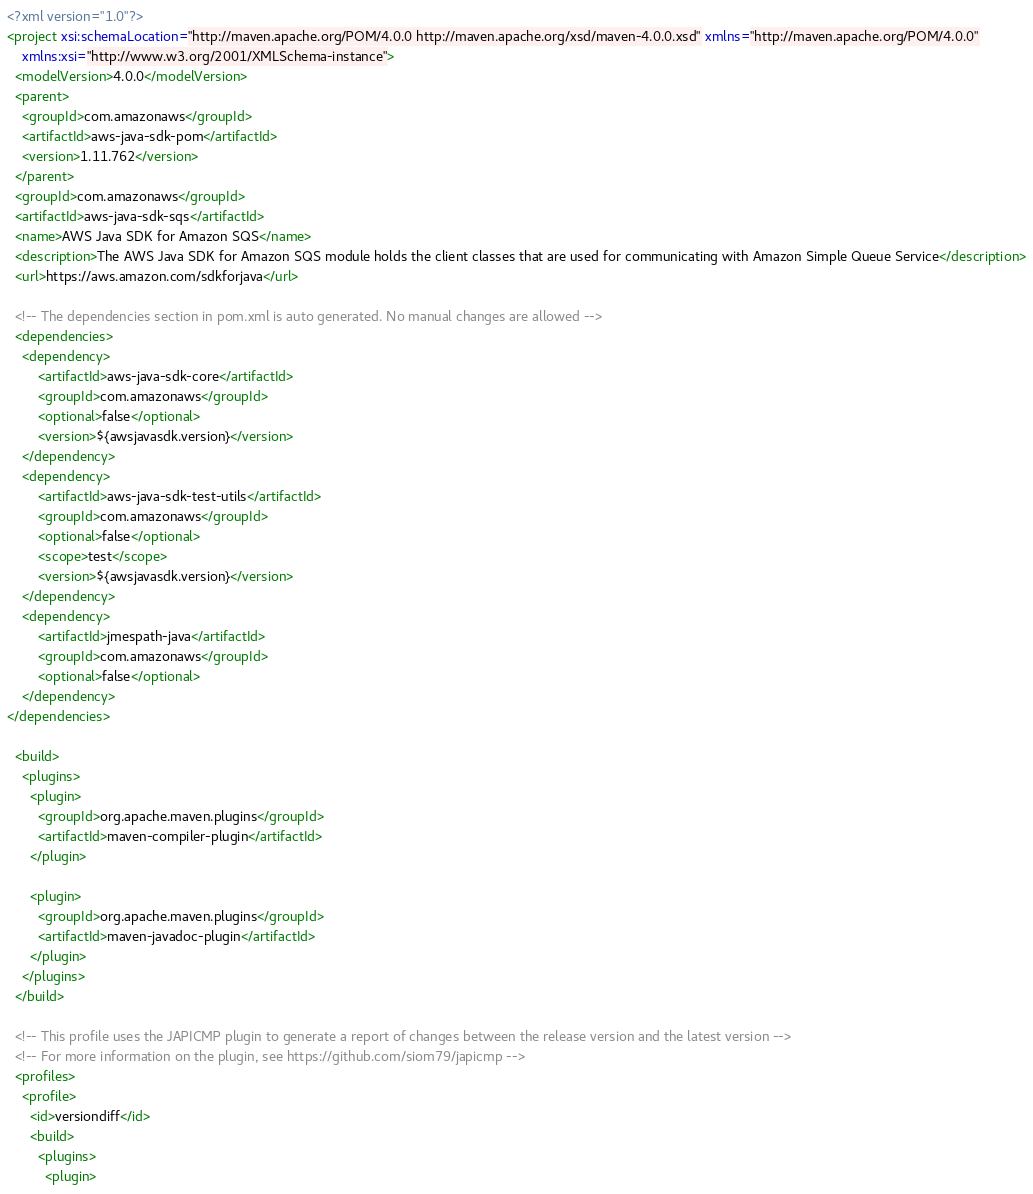Convert code to text. <code><loc_0><loc_0><loc_500><loc_500><_XML_><?xml version="1.0"?>
<project xsi:schemaLocation="http://maven.apache.org/POM/4.0.0 http://maven.apache.org/xsd/maven-4.0.0.xsd" xmlns="http://maven.apache.org/POM/4.0.0"
    xmlns:xsi="http://www.w3.org/2001/XMLSchema-instance">
  <modelVersion>4.0.0</modelVersion>
  <parent>
    <groupId>com.amazonaws</groupId>
    <artifactId>aws-java-sdk-pom</artifactId>
    <version>1.11.762</version>
  </parent>
  <groupId>com.amazonaws</groupId>
  <artifactId>aws-java-sdk-sqs</artifactId>
  <name>AWS Java SDK for Amazon SQS</name>
  <description>The AWS Java SDK for Amazon SQS module holds the client classes that are used for communicating with Amazon Simple Queue Service</description>
  <url>https://aws.amazon.com/sdkforjava</url>

  <!-- The dependencies section in pom.xml is auto generated. No manual changes are allowed -->
  <dependencies>
    <dependency>
        <artifactId>aws-java-sdk-core</artifactId>
        <groupId>com.amazonaws</groupId>
        <optional>false</optional>
        <version>${awsjavasdk.version}</version>
    </dependency>
    <dependency>
        <artifactId>aws-java-sdk-test-utils</artifactId>
        <groupId>com.amazonaws</groupId>
        <optional>false</optional>
        <scope>test</scope>
        <version>${awsjavasdk.version}</version>
    </dependency>
    <dependency>
        <artifactId>jmespath-java</artifactId>
        <groupId>com.amazonaws</groupId>
        <optional>false</optional>
    </dependency>
</dependencies>

  <build>
    <plugins>
      <plugin>
        <groupId>org.apache.maven.plugins</groupId>
        <artifactId>maven-compiler-plugin</artifactId>
      </plugin>

      <plugin>
        <groupId>org.apache.maven.plugins</groupId>
        <artifactId>maven-javadoc-plugin</artifactId>
      </plugin>
    </plugins>
  </build>

  <!-- This profile uses the JAPICMP plugin to generate a report of changes between the release version and the latest version -->
  <!-- For more information on the plugin, see https://github.com/siom79/japicmp -->
  <profiles>
    <profile>
      <id>versiondiff</id>
      <build>
        <plugins>
          <plugin></code> 